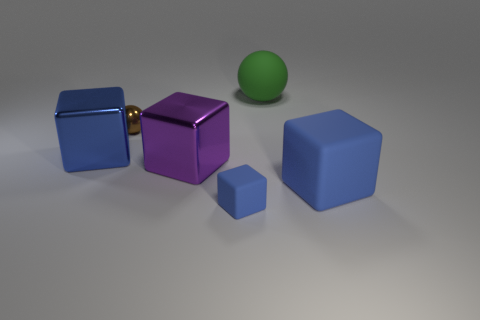What number of big objects are blue matte blocks or blue things?
Make the answer very short. 2. Does the large block that is on the left side of the brown sphere have the same material as the small brown sphere?
Offer a very short reply. Yes. There is a big thing left of the sphere in front of the large green object; what is its material?
Offer a very short reply. Metal. How many big green objects are the same shape as the tiny blue rubber thing?
Offer a terse response. 0. What size is the purple metal cube on the left side of the large blue block that is in front of the big object to the left of the small metallic object?
Ensure brevity in your answer.  Large. How many purple things are spheres or big blocks?
Ensure brevity in your answer.  1. There is a rubber thing that is behind the tiny sphere; is it the same shape as the blue shiny object?
Your answer should be compact. No. Is the number of small shiny balls in front of the green rubber object greater than the number of blue metallic cubes?
Your answer should be compact. No. What number of purple objects have the same size as the brown shiny thing?
Give a very brief answer. 0. What size is the matte object that is the same color as the tiny rubber cube?
Give a very brief answer. Large. 